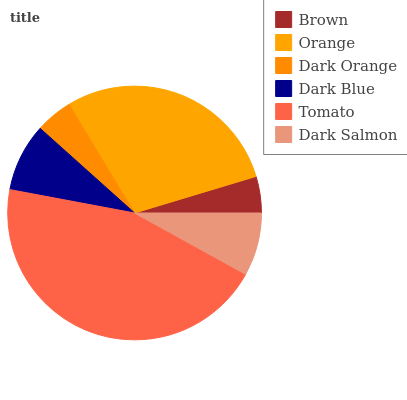Is Brown the minimum?
Answer yes or no. Yes. Is Tomato the maximum?
Answer yes or no. Yes. Is Orange the minimum?
Answer yes or no. No. Is Orange the maximum?
Answer yes or no. No. Is Orange greater than Brown?
Answer yes or no. Yes. Is Brown less than Orange?
Answer yes or no. Yes. Is Brown greater than Orange?
Answer yes or no. No. Is Orange less than Brown?
Answer yes or no. No. Is Dark Blue the high median?
Answer yes or no. Yes. Is Dark Salmon the low median?
Answer yes or no. Yes. Is Tomato the high median?
Answer yes or no. No. Is Dark Blue the low median?
Answer yes or no. No. 